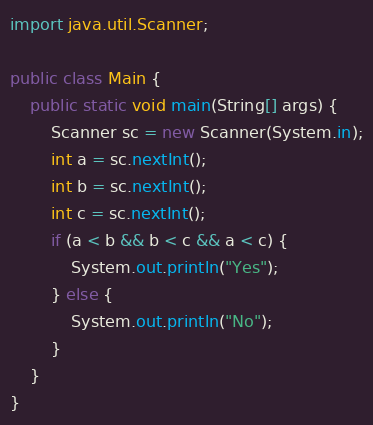<code> <loc_0><loc_0><loc_500><loc_500><_Java_>import java.util.Scanner;

public class Main {
	public static void main(String[] args) {
		Scanner sc = new Scanner(System.in);
		int a = sc.nextInt();
		int b = sc.nextInt();
		int c = sc.nextInt();
		if (a < b && b < c && a < c) {
			System.out.println("Yes");
		} else {
			System.out.println("No");
		}
	}
}</code> 